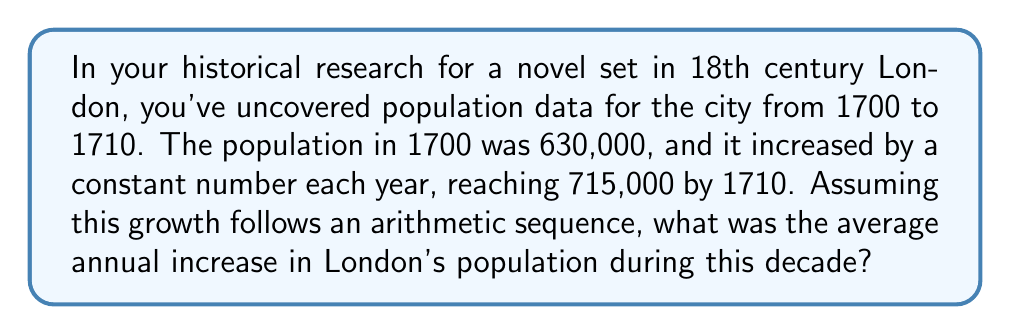Teach me how to tackle this problem. Let's approach this step-by-step using the properties of arithmetic sequences:

1) In an arithmetic sequence, the difference between each term is constant. Let's call this common difference $d$.

2) We know:
   - Initial population (1700): $a_1 = 630,000$
   - Final population (1710): $a_{11} = 715,000$
   - Number of terms: $n = 11$ (1700 to 1710 inclusive)

3) For an arithmetic sequence, the nth term is given by:
   $a_n = a_1 + (n-1)d$

4) Substituting our known values:
   $715,000 = 630,000 + (11-1)d$

5) Simplifying:
   $715,000 = 630,000 + 10d$

6) Subtracting 630,000 from both sides:
   $85,000 = 10d$

7) Dividing both sides by 10:
   $8,500 = d$

Therefore, the population increased by 8,500 people each year on average.
Answer: 8,500 people per year 